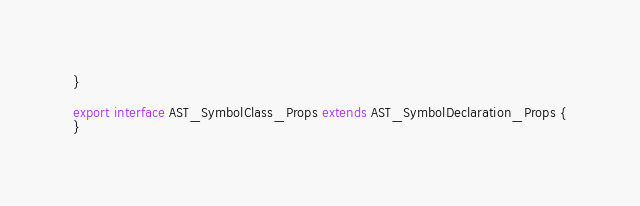Convert code to text. <code><loc_0><loc_0><loc_500><loc_500><_TypeScript_>}

export interface AST_SymbolClass_Props extends AST_SymbolDeclaration_Props {
}
</code> 